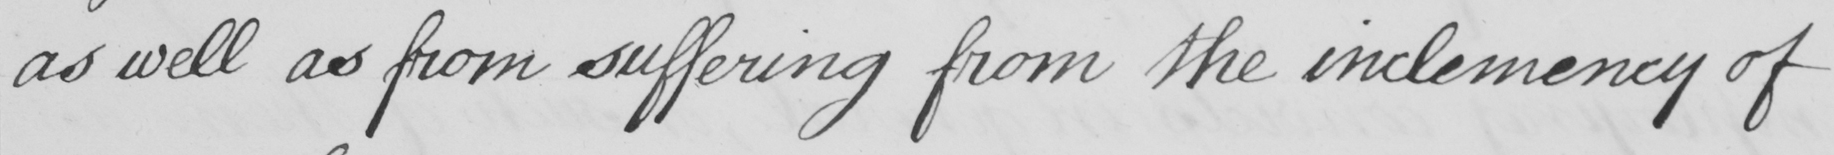Please provide the text content of this handwritten line. as well as from suffering from the inclemency of 